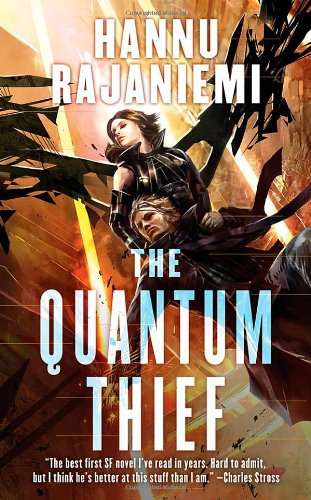What is the title of this book? The title displayed on the vibrant book cover is 'The Quantum Thief', part of the Jean le Flambeur series that dives into themes of quantum technology and intricate heists. 